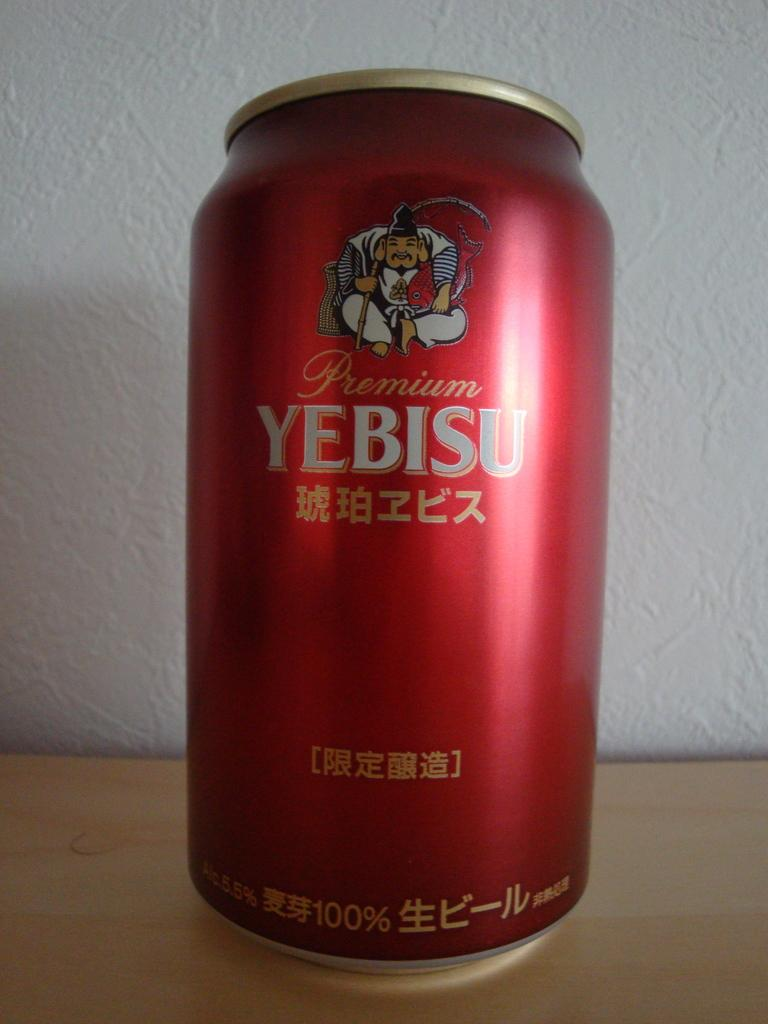<image>
Provide a brief description of the given image. A red canned beveraged is labelled Premium Yebisu. 